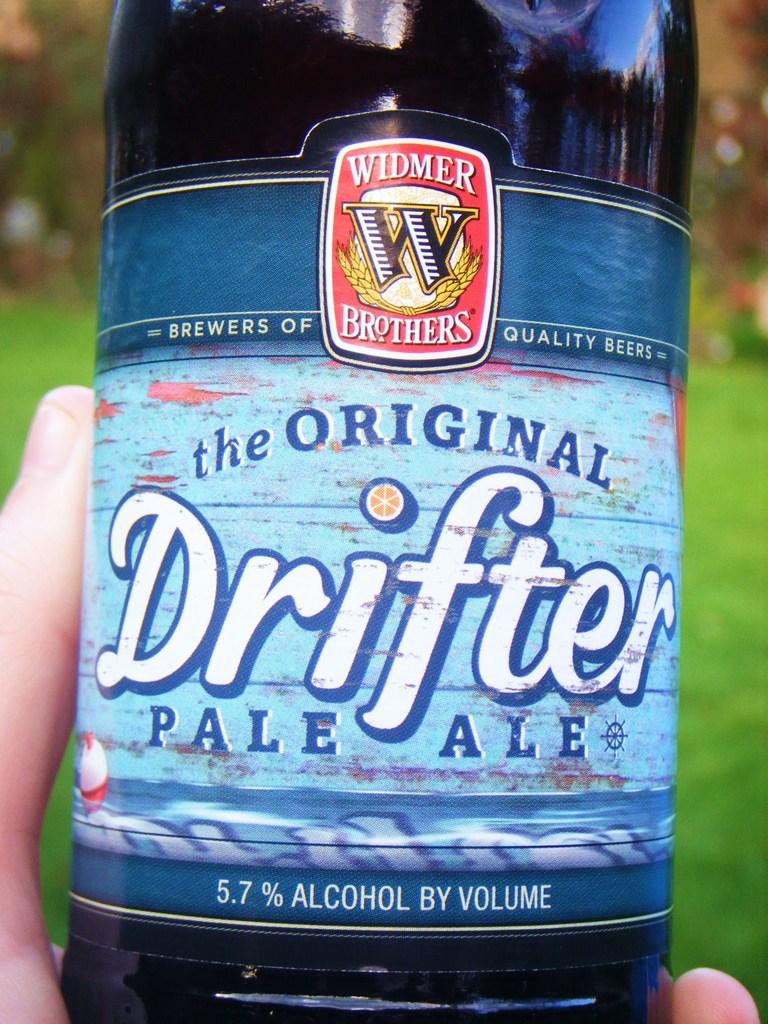What is the alcohol content?
Offer a terse response. 5.7%. 